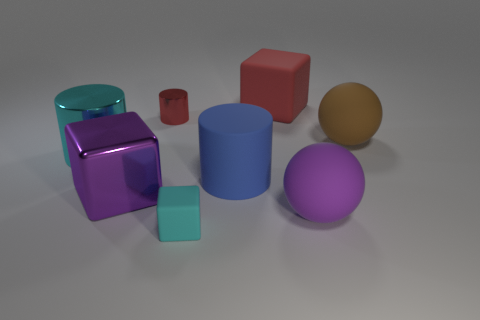Is the material of the small cyan object the same as the purple thing on the right side of the large red cube?
Your answer should be compact. Yes. Is the number of purple rubber spheres to the left of the small red cylinder less than the number of cyan cubes that are behind the cyan cylinder?
Keep it short and to the point. No. What color is the cylinder that is on the right side of the small red object?
Your answer should be very brief. Blue. How many other objects are there of the same color as the metal cube?
Keep it short and to the point. 1. Do the metal cylinder on the right side of the cyan shiny cylinder and the large purple sphere have the same size?
Offer a very short reply. No. There is a big purple block; how many cyan shiny cylinders are to the right of it?
Make the answer very short. 0. Is there a cyan block that has the same size as the purple rubber object?
Your response must be concise. No. Is the color of the small metallic cylinder the same as the big matte cylinder?
Keep it short and to the point. No. There is a shiny cylinder on the left side of the small object that is behind the big purple ball; what color is it?
Provide a short and direct response. Cyan. What number of large cylinders are both left of the tiny red object and to the right of the tiny red object?
Offer a terse response. 0. 